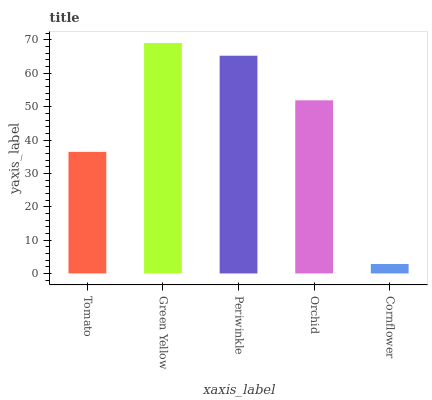Is Cornflower the minimum?
Answer yes or no. Yes. Is Green Yellow the maximum?
Answer yes or no. Yes. Is Periwinkle the minimum?
Answer yes or no. No. Is Periwinkle the maximum?
Answer yes or no. No. Is Green Yellow greater than Periwinkle?
Answer yes or no. Yes. Is Periwinkle less than Green Yellow?
Answer yes or no. Yes. Is Periwinkle greater than Green Yellow?
Answer yes or no. No. Is Green Yellow less than Periwinkle?
Answer yes or no. No. Is Orchid the high median?
Answer yes or no. Yes. Is Orchid the low median?
Answer yes or no. Yes. Is Green Yellow the high median?
Answer yes or no. No. Is Tomato the low median?
Answer yes or no. No. 